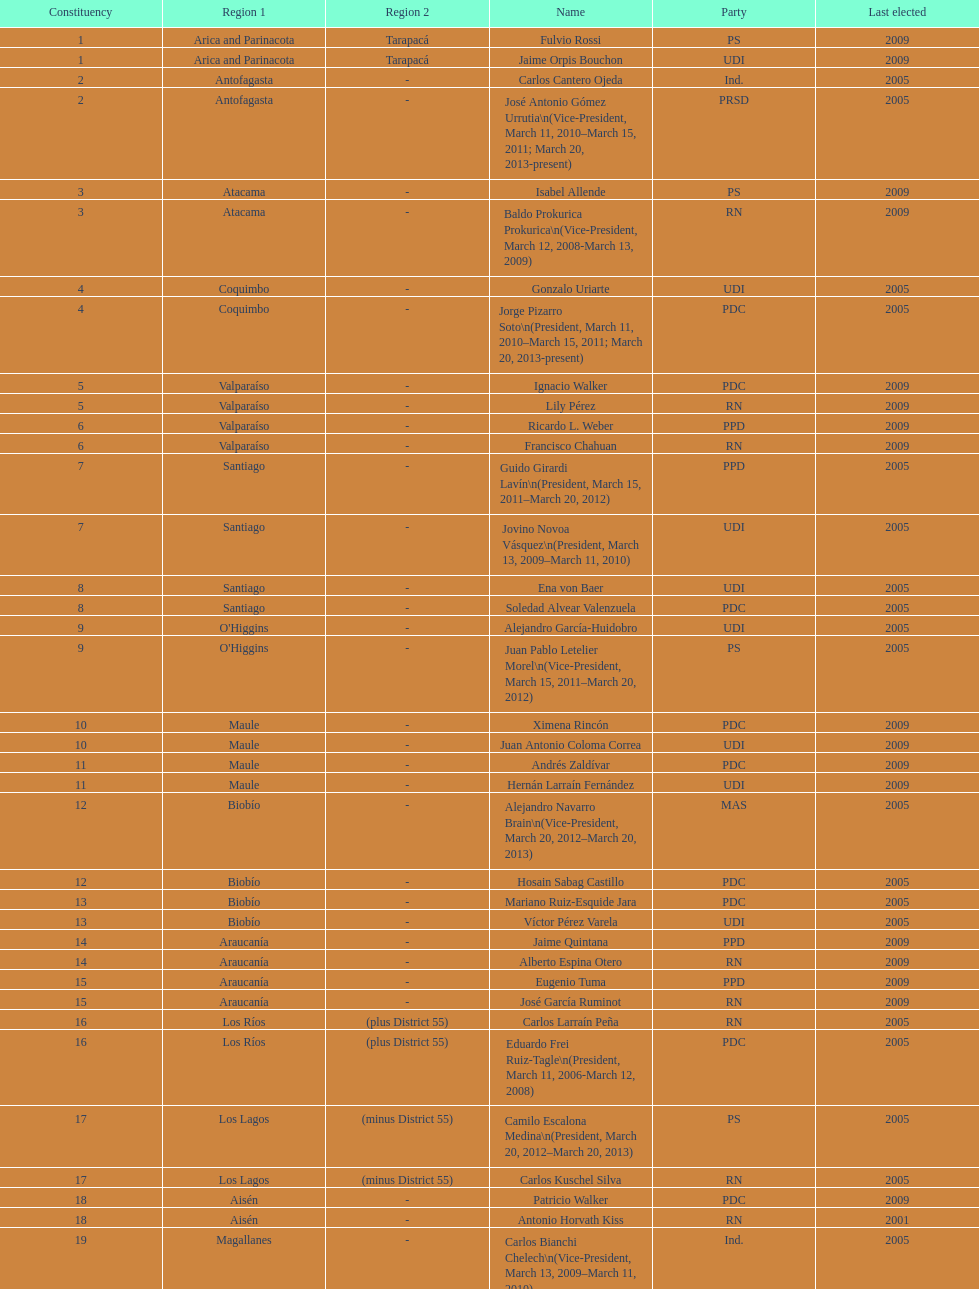When was antonio horvath kiss last elected? 2001. 